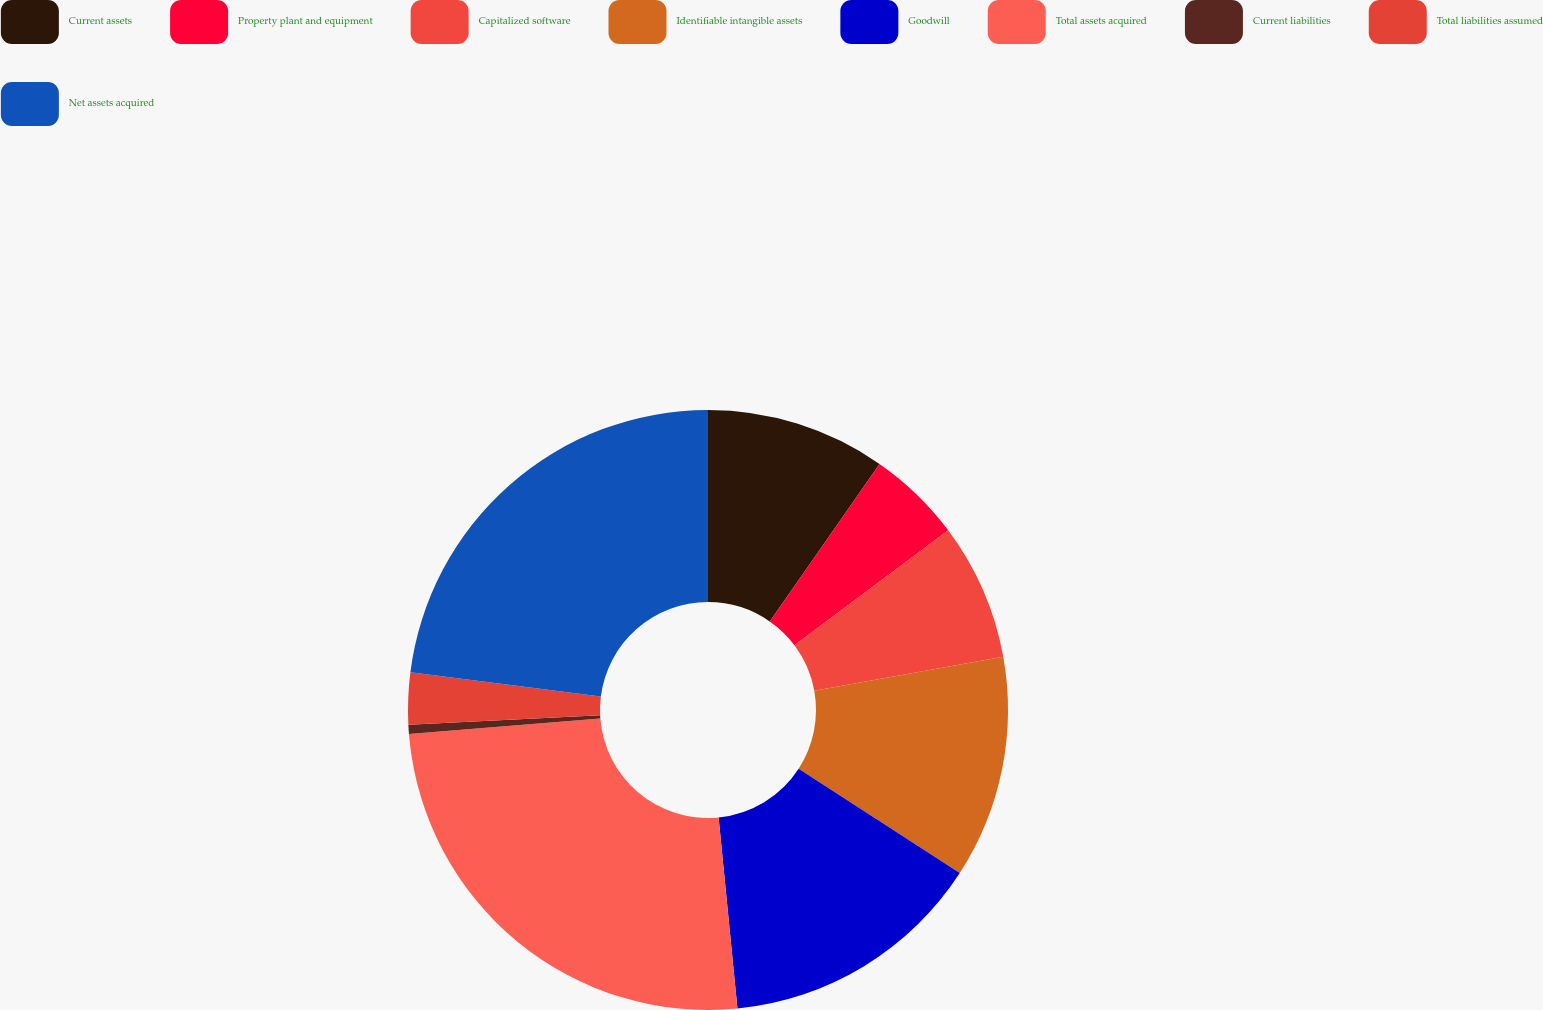Convert chart to OTSL. <chart><loc_0><loc_0><loc_500><loc_500><pie_chart><fcel>Current assets<fcel>Property plant and equipment<fcel>Capitalized software<fcel>Identifiable intangible assets<fcel>Goodwill<fcel>Total assets acquired<fcel>Current liabilities<fcel>Total liabilities assumed<fcel>Net assets acquired<nl><fcel>9.69%<fcel>5.09%<fcel>7.39%<fcel>11.99%<fcel>14.29%<fcel>25.3%<fcel>0.49%<fcel>2.79%<fcel>23.0%<nl></chart> 